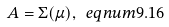<formula> <loc_0><loc_0><loc_500><loc_500>A = \Sigma ( \mu ) , \ e q n u m { 9 . 1 6 }</formula> 